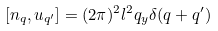Convert formula to latex. <formula><loc_0><loc_0><loc_500><loc_500>[ n _ { q } , u _ { { q } ^ { \prime } } ] = ( 2 \pi ) ^ { 2 } l ^ { 2 } q _ { y } \delta ( { q } + { q } ^ { \prime } )</formula> 